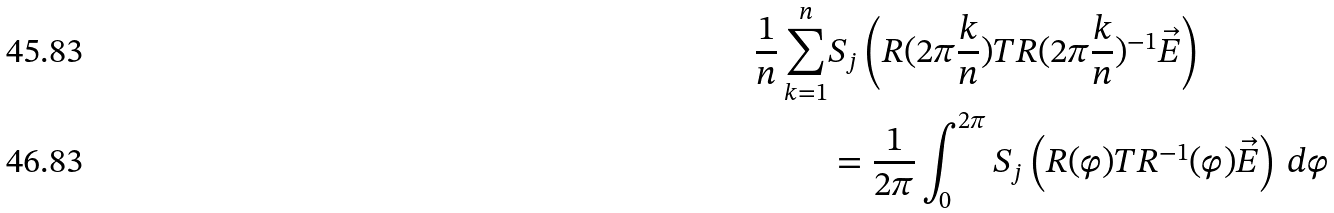<formula> <loc_0><loc_0><loc_500><loc_500>\frac { 1 } { n } \sum _ { k = 1 } ^ { n } & S _ { j } \left ( R ( { 2 \pi \frac { k } { n } } ) T R ( { 2 \pi \frac { k } { n } } ) ^ { - 1 } \vec { E } \right ) \\ & = \frac { 1 } { 2 \pi } \int _ { 0 } ^ { 2 \pi } S _ { j } \left ( R ( \varphi ) T R ^ { - 1 } ( \varphi ) \vec { E } \right ) \, d \varphi</formula> 